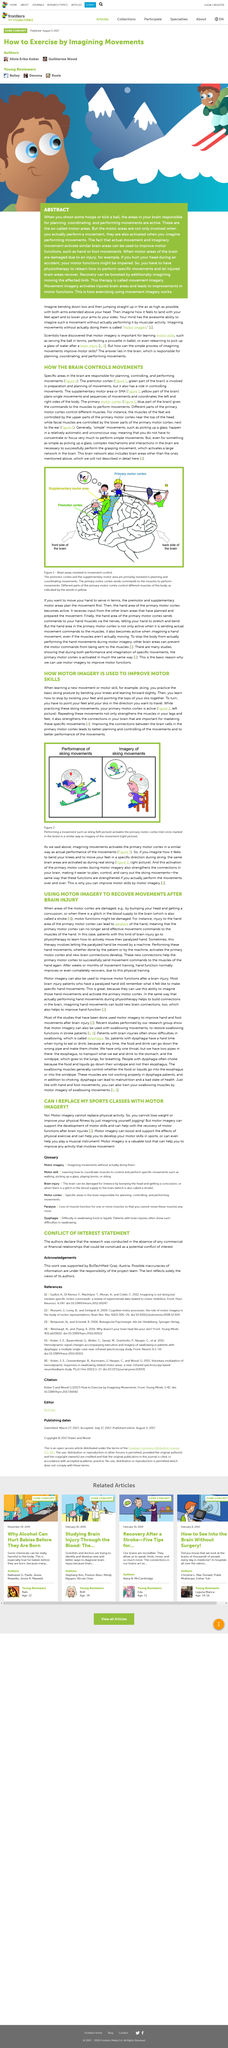Mention a couple of crucial points in this snapshot. Motor imagery can enhance the benefits of physical exercise. During the practice of skiing movements, the primary motor cortex is actively involved in controlling and coordinating the movements of the body. Improving the connections between brain cells in the primary motor cortex leads to improved planning and control of movements, resulting in better performance of movements. Motor imagery can assist in the learning of a musical instrument. When learning a new movement or motor skill, practicing the basic posture involves bending the knees and leaning forward slightly. 